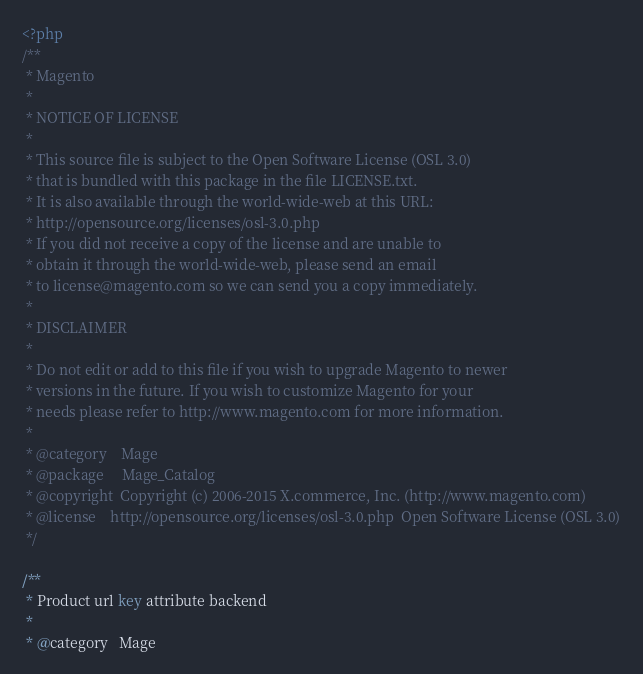Convert code to text. <code><loc_0><loc_0><loc_500><loc_500><_PHP_><?php
/**
 * Magento
 *
 * NOTICE OF LICENSE
 *
 * This source file is subject to the Open Software License (OSL 3.0)
 * that is bundled with this package in the file LICENSE.txt.
 * It is also available through the world-wide-web at this URL:
 * http://opensource.org/licenses/osl-3.0.php
 * If you did not receive a copy of the license and are unable to
 * obtain it through the world-wide-web, please send an email
 * to license@magento.com so we can send you a copy immediately.
 *
 * DISCLAIMER
 *
 * Do not edit or add to this file if you wish to upgrade Magento to newer
 * versions in the future. If you wish to customize Magento for your
 * needs please refer to http://www.magento.com for more information.
 *
 * @category    Mage
 * @package     Mage_Catalog
 * @copyright  Copyright (c) 2006-2015 X.commerce, Inc. (http://www.magento.com)
 * @license    http://opensource.org/licenses/osl-3.0.php  Open Software License (OSL 3.0)
 */

/**
 * Product url key attribute backend
 *
 * @category   Mage</code> 